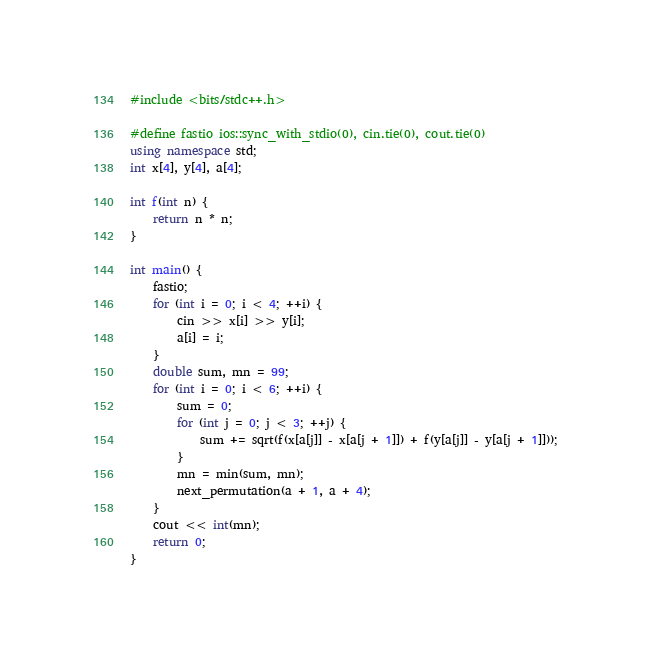Convert code to text. <code><loc_0><loc_0><loc_500><loc_500><_C++_>#include <bits/stdc++.h>

#define fastio ios::sync_with_stdio(0), cin.tie(0), cout.tie(0)
using namespace std;
int x[4], y[4], a[4];

int f(int n) {
    return n * n;
}

int main() {
    fastio;
    for (int i = 0; i < 4; ++i) {
        cin >> x[i] >> y[i];
        a[i] = i;
    }
    double sum, mn = 99;
    for (int i = 0; i < 6; ++i) {
        sum = 0;
        for (int j = 0; j < 3; ++j) {
            sum += sqrt(f(x[a[j]] - x[a[j + 1]]) + f(y[a[j]] - y[a[j + 1]]));
        }
        mn = min(sum, mn);
        next_permutation(a + 1, a + 4);
    }
    cout << int(mn);
    return 0;
}</code> 